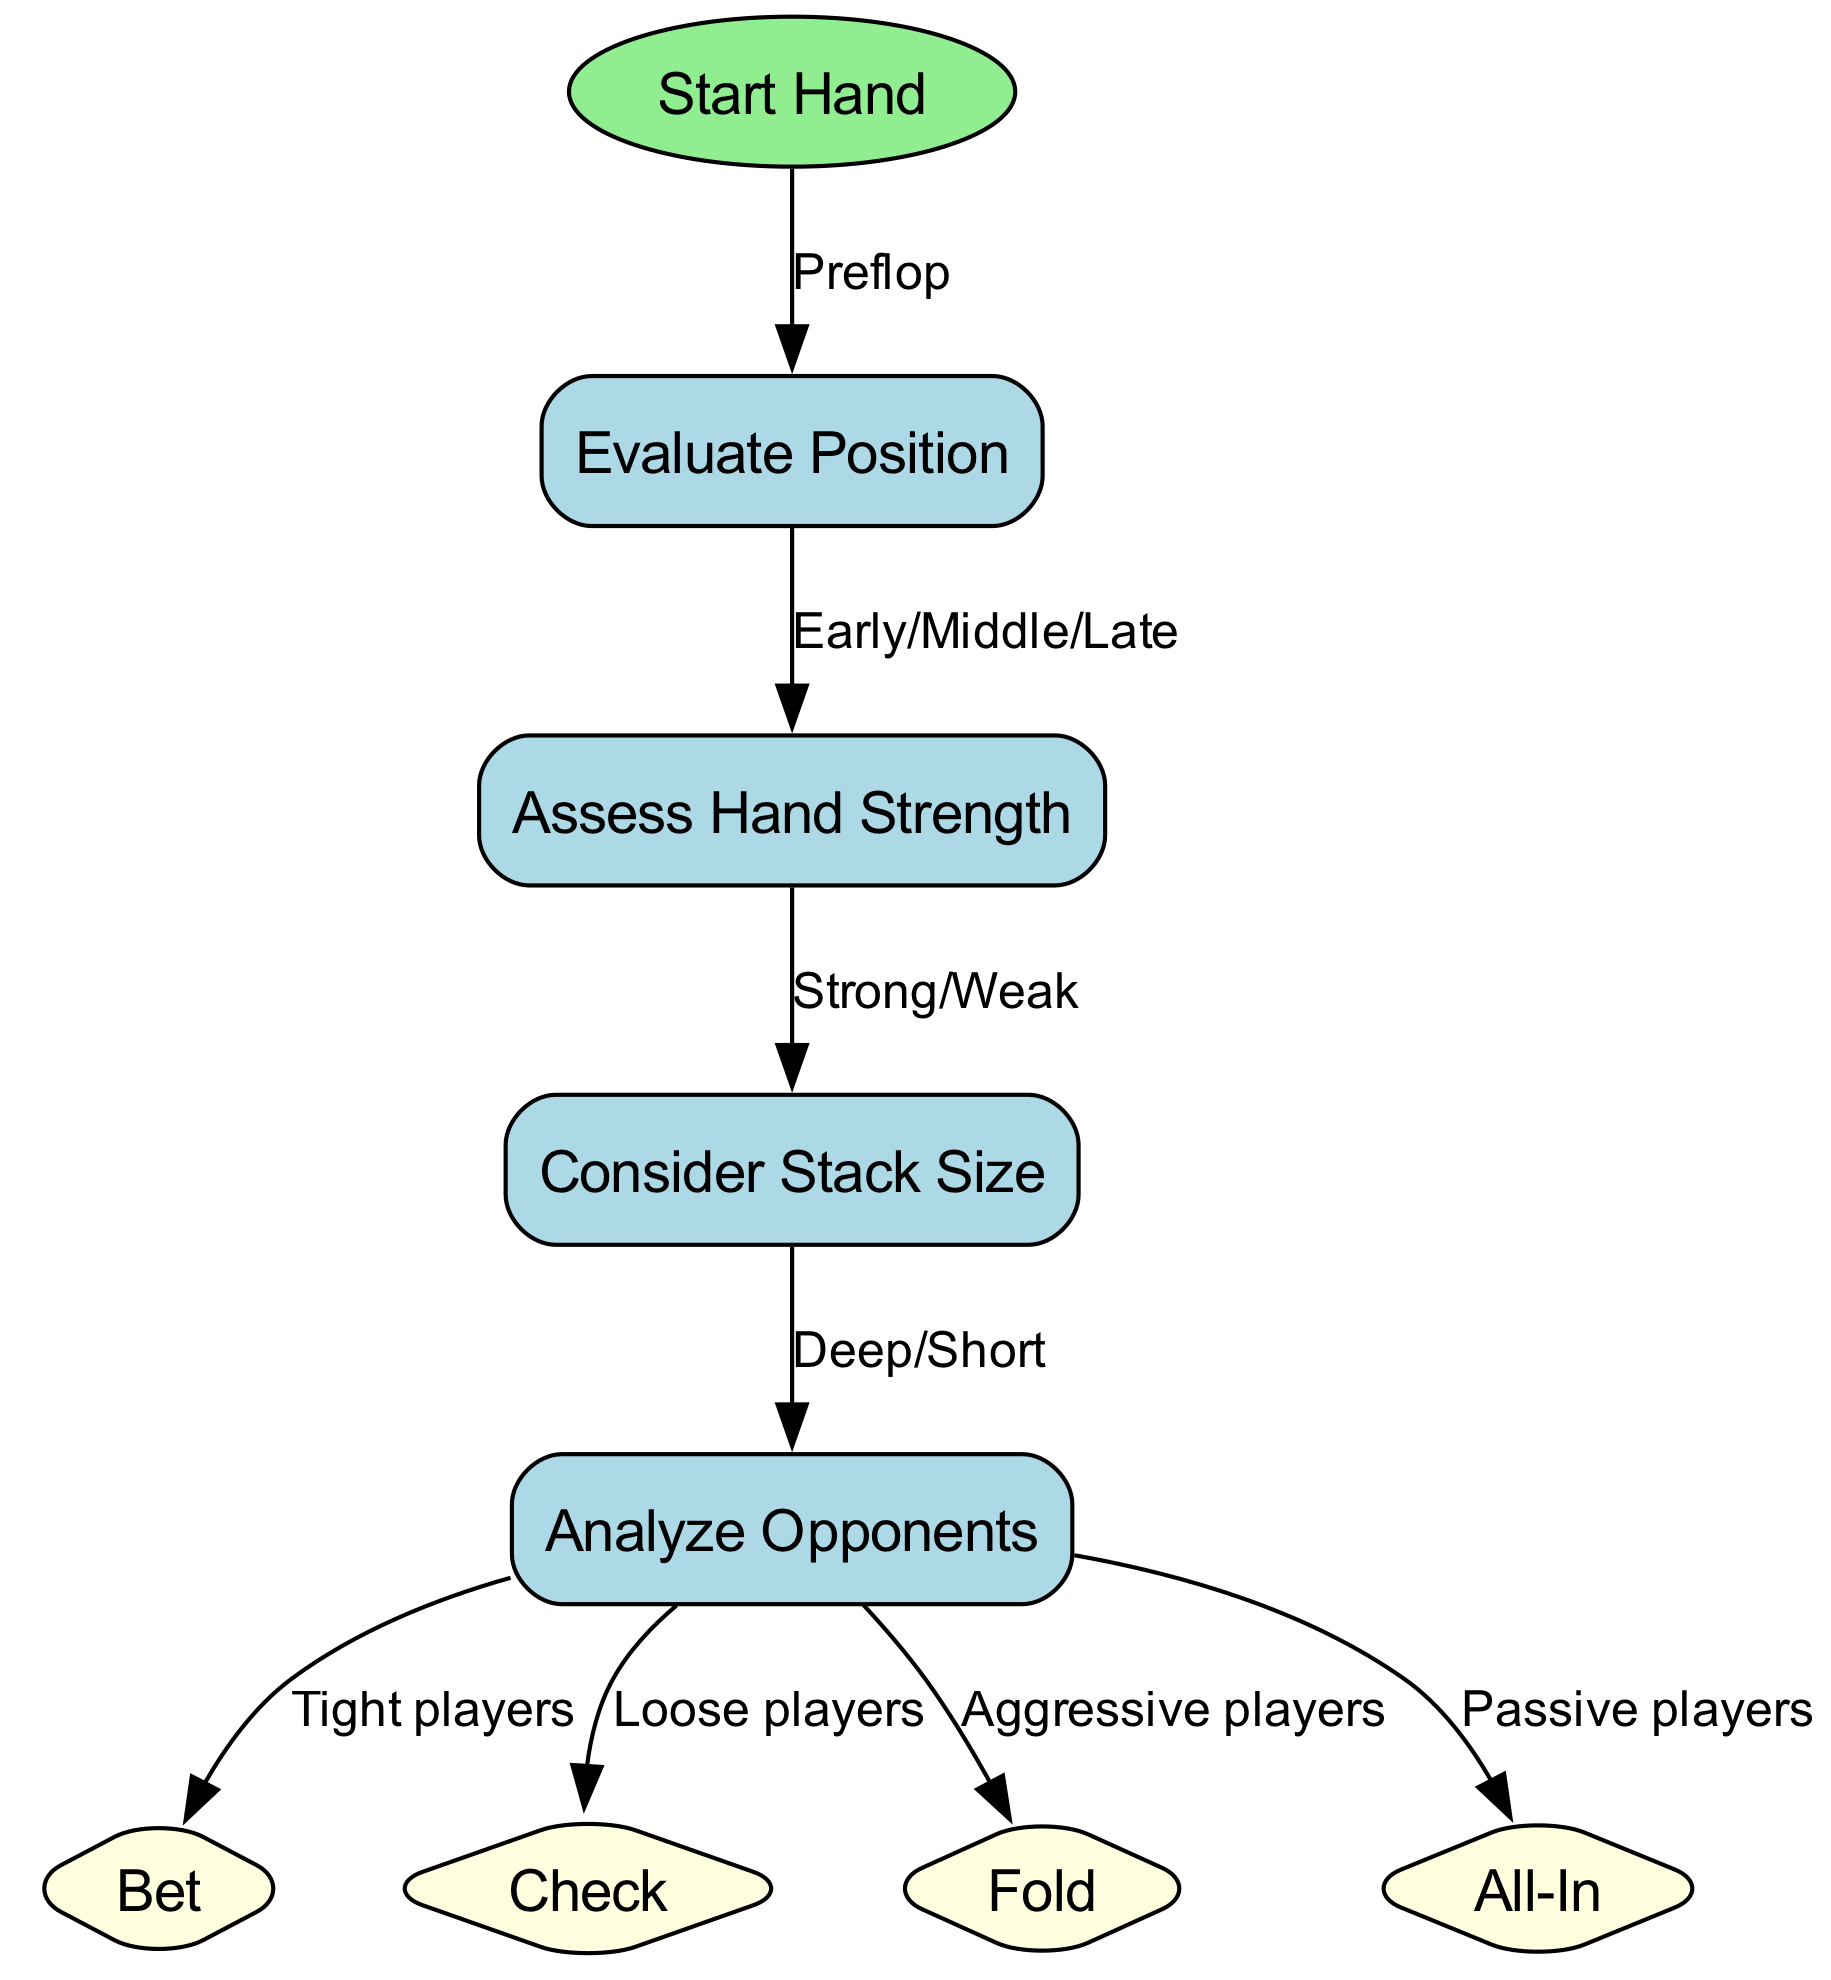What is the first node in the diagram? The first node in the diagram is labeled "Start Hand". It is indicated in the data as the node with the id "start".
Answer: Start Hand How many nodes are there in total in the diagram? By counting the nodes listed in the data, there are a total of 8 nodes present in the diagram.
Answer: 8 Which node follows "Evaluate Position"? Following "Evaluate Position", the next node is "Assess Hand Strength", as indicated in the edges that connect these two nodes.
Answer: Assess Hand Strength What action is recommended when facing tight players? The diagram suggests to "Bet" when facing tight players, as shown in the edge that leads from the "Analyze Opponents" node to the "Bet" node.
Answer: Bet If the hand strength is assessed as weak, what should be considered next? After assessing hand strength as weak, the next consideration mentioned is "Consider Stack Size", as it is the next node in the flow after "Assess Hand Strength".
Answer: Consider Stack Size What decision should you take if your opponents are aggressive? According to the flow from the "Analyze Opponents" node, you should "Fold" if your opponents are aggressive players.
Answer: Fold What does the "Fold" node represent in this context? The "Fold" node represents a decision to give up on the hand when the analysis suggests that the potential loss is greater than the risk of continuing. It is a strategy employed based on the type of opponent.
Answer: Fold What are the four potential actions in the decision-making process? The potential actions in the decision-making process are "Bet", "Check", "Fold", and "All-In", as indicated by the respective nodes in the diagram.
Answer: Bet, Check, Fold, All-In Which node represents the condition of being in a deep stack situation? The node representing the condition of being in a deep stack situation is "Consider Stack Size", as it indicates a consideration related to the size of the stacks.
Answer: Consider Stack Size 